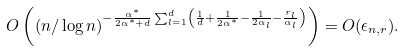<formula> <loc_0><loc_0><loc_500><loc_500>O \left ( ( n / \log { n } ) ^ { - \frac { \alpha ^ { * } } { 2 \alpha ^ { * } + d } \sum _ { l = 1 } ^ { d } \left ( \frac { 1 } { d } + \frac { 1 } { 2 \alpha ^ { * } } - \frac { 1 } { 2 \alpha _ { l } } - \frac { r _ { l } } { \alpha _ { l } } \right ) } \right ) = O ( \epsilon _ { n , r } ) .</formula> 